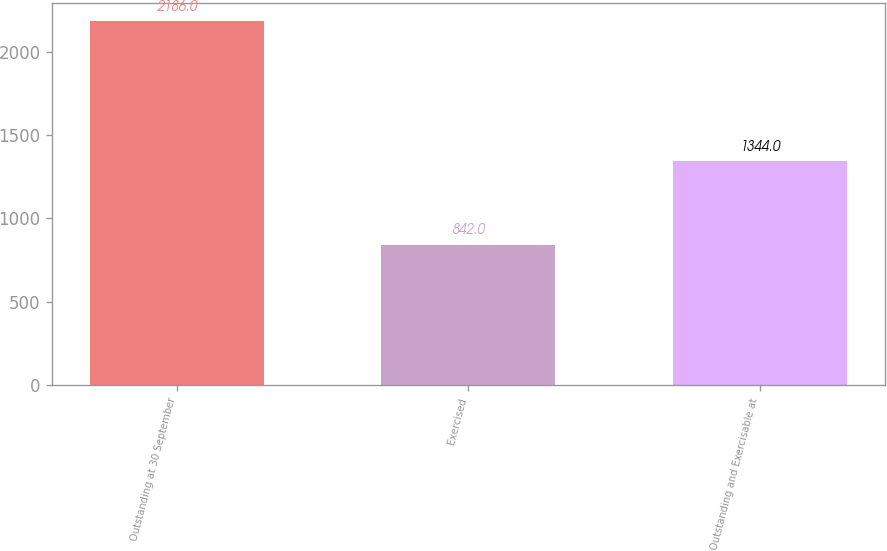Convert chart. <chart><loc_0><loc_0><loc_500><loc_500><bar_chart><fcel>Outstanding at 30 September<fcel>Exercised<fcel>Outstanding and Exercisable at<nl><fcel>2186<fcel>842<fcel>1344<nl></chart> 